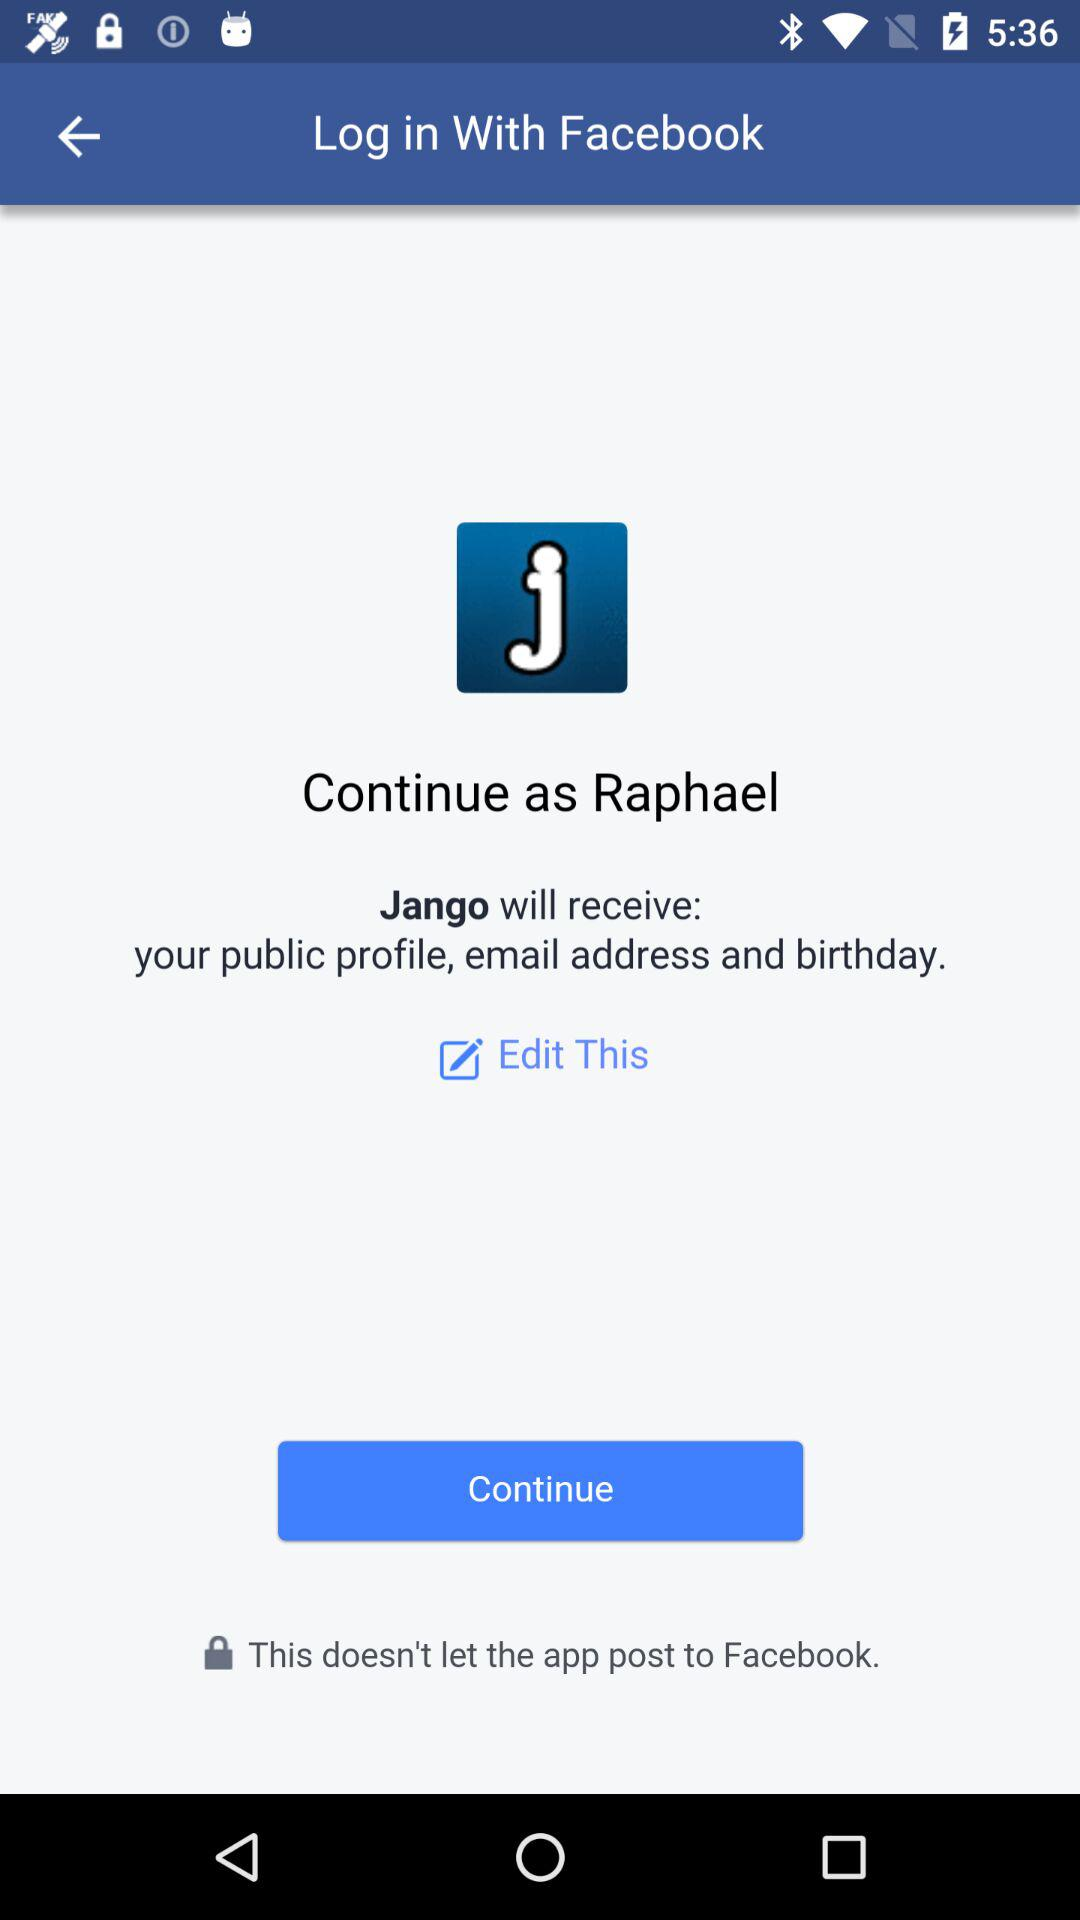Through what application can we log in? You can log in through "Facebook". 